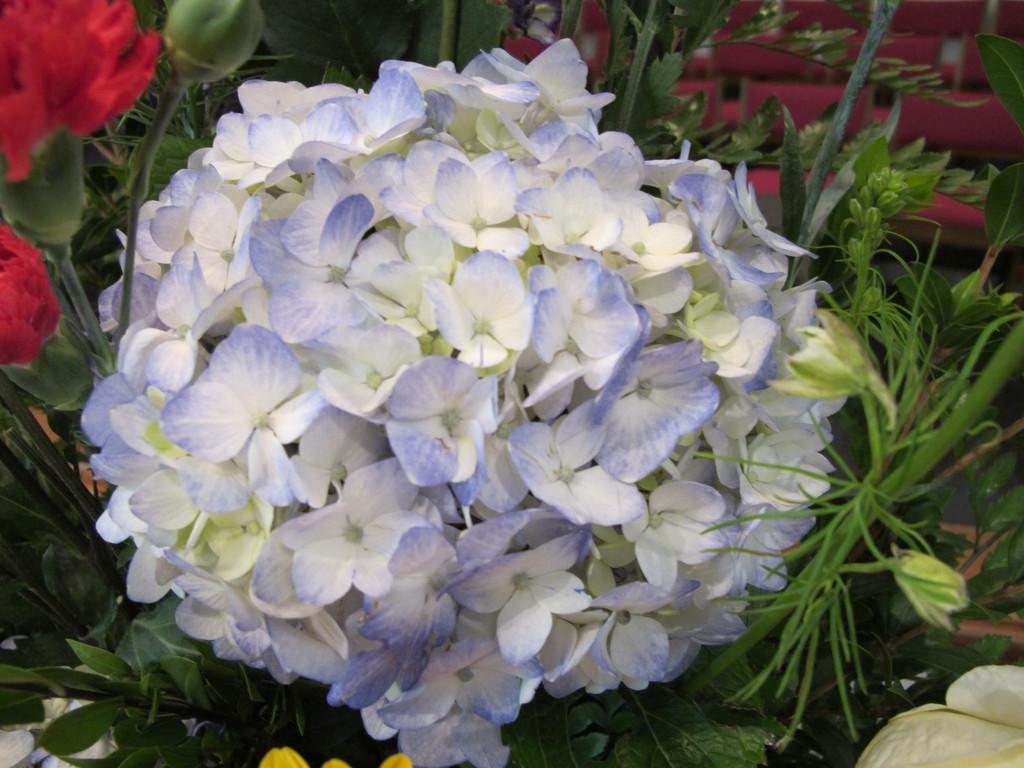Please provide a concise description of this image. In this picture we can see flowers of different colors and in the background we can see leaves. 